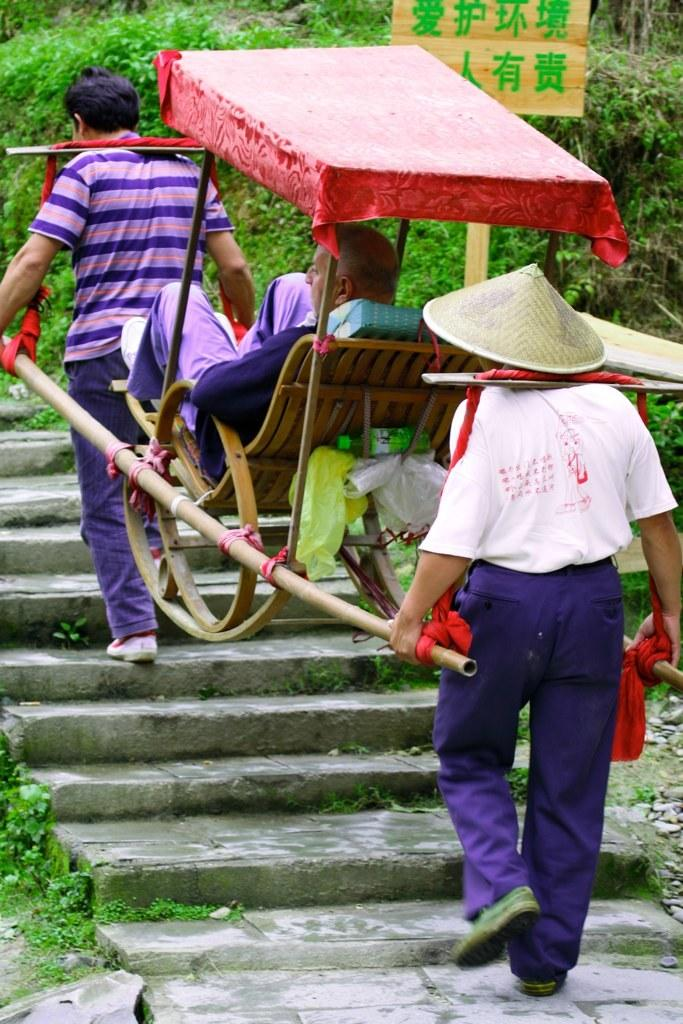How many people are in the image? There are two men in the image. What are the men doing in the image? The men are carrying a person in a wooden carriage. Where are the men walking in the image? The men are walking on steps. What type of vegetation is present in the image? There are plants and grass in the image. What can be used to identify the location in the image? There is a name board in the image. How many clocks are hanging on the walls in the image? There are no clocks visible in the image. What type of beds can be seen in the image? There are no beds present in the image. 